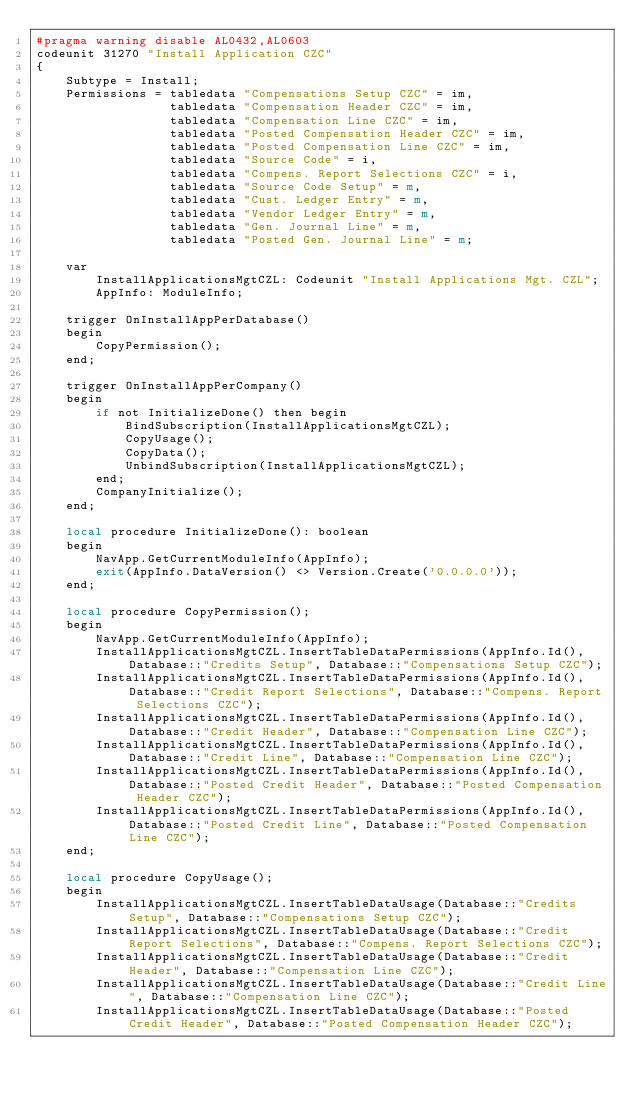<code> <loc_0><loc_0><loc_500><loc_500><_Perl_>#pragma warning disable AL0432,AL0603
codeunit 31270 "Install Application CZC"
{
    Subtype = Install;
    Permissions = tabledata "Compensations Setup CZC" = im,
                  tabledata "Compensation Header CZC" = im,
                  tabledata "Compensation Line CZC" = im,
                  tabledata "Posted Compensation Header CZC" = im,
                  tabledata "Posted Compensation Line CZC" = im,
                  tabledata "Source Code" = i,
                  tabledata "Compens. Report Selections CZC" = i,
                  tabledata "Source Code Setup" = m,
                  tabledata "Cust. Ledger Entry" = m,
                  tabledata "Vendor Ledger Entry" = m,
                  tabledata "Gen. Journal Line" = m,
                  tabledata "Posted Gen. Journal Line" = m;

    var
        InstallApplicationsMgtCZL: Codeunit "Install Applications Mgt. CZL";
        AppInfo: ModuleInfo;

    trigger OnInstallAppPerDatabase()
    begin
        CopyPermission();
    end;

    trigger OnInstallAppPerCompany()
    begin
        if not InitializeDone() then begin
            BindSubscription(InstallApplicationsMgtCZL);
            CopyUsage();
            CopyData();
            UnbindSubscription(InstallApplicationsMgtCZL);
        end;
        CompanyInitialize();
    end;

    local procedure InitializeDone(): boolean
    begin
        NavApp.GetCurrentModuleInfo(AppInfo);
        exit(AppInfo.DataVersion() <> Version.Create('0.0.0.0'));
    end;

    local procedure CopyPermission();
    begin
        NavApp.GetCurrentModuleInfo(AppInfo);
        InstallApplicationsMgtCZL.InsertTableDataPermissions(AppInfo.Id(), Database::"Credits Setup", Database::"Compensations Setup CZC");
        InstallApplicationsMgtCZL.InsertTableDataPermissions(AppInfo.Id(), Database::"Credit Report Selections", Database::"Compens. Report Selections CZC");
        InstallApplicationsMgtCZL.InsertTableDataPermissions(AppInfo.Id(), Database::"Credit Header", Database::"Compensation Line CZC");
        InstallApplicationsMgtCZL.InsertTableDataPermissions(AppInfo.Id(), Database::"Credit Line", Database::"Compensation Line CZC");
        InstallApplicationsMgtCZL.InsertTableDataPermissions(AppInfo.Id(), Database::"Posted Credit Header", Database::"Posted Compensation Header CZC");
        InstallApplicationsMgtCZL.InsertTableDataPermissions(AppInfo.Id(), Database::"Posted Credit Line", Database::"Posted Compensation Line CZC");
    end;

    local procedure CopyUsage();
    begin
        InstallApplicationsMgtCZL.InsertTableDataUsage(Database::"Credits Setup", Database::"Compensations Setup CZC");
        InstallApplicationsMgtCZL.InsertTableDataUsage(Database::"Credit Report Selections", Database::"Compens. Report Selections CZC");
        InstallApplicationsMgtCZL.InsertTableDataUsage(Database::"Credit Header", Database::"Compensation Line CZC");
        InstallApplicationsMgtCZL.InsertTableDataUsage(Database::"Credit Line", Database::"Compensation Line CZC");
        InstallApplicationsMgtCZL.InsertTableDataUsage(Database::"Posted Credit Header", Database::"Posted Compensation Header CZC");</code> 